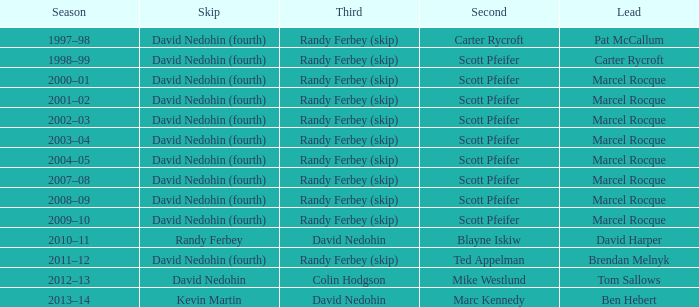Which Skip has a Season of 2002–03? David Nedohin (fourth). 